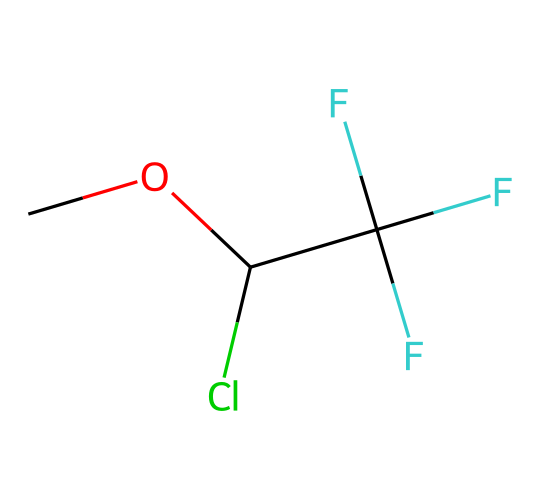What is the molecular formula of methoxyflurane? By analyzing the SMILES representation, we can extract the components: C, O, Cl, and F. Counting gives 4 carbon atoms, 1 oxygen atom, 1 chlorine atom, and 3 fluorine atoms. Thus, the molecular formula is C4H3ClF3O.
Answer: C4H3ClF3O How many different types of atoms are present in this molecule? The SMILES shows the presence of carbon (C), oxygen (O), chlorine (Cl), and fluorine (F). When counting the unique types of atoms, we find there are 4 different types: C, O, Cl, and F.
Answer: 4 What functional group is present in methoxyflurane? The chemical structure indicates that there is an ether functional group characterized by the presence of an oxygen atom connected to two carbon atoms (C-O-C). This defines the ether functional group.
Answer: ether Which part of the molecule indicates its anesthetic properties? The presence of fluorinated carbon atoms, specifically the trifluoromethyl group (C(F)(F)F), is a characteristic feature of many anesthetics due to their ability to affect neural activity, leading to anesthetic properties.
Answer: trifluoromethyl group How many carbon-fluorine bonds are present? By inspecting the structure, we conclude that there are 3 fluorine atoms attached to a single carbon atom, leading to a total of 3 carbon-fluorine bonds.
Answer: 3 What role does the chlorine atom play in methoxyflurane? The chlorine atom can enhance the molecule's stability as well as influence its anesthetic properties by affecting the lipophilicity and potency of the compound, given that halogen atoms often modify reactivity.
Answer: enhance stability 